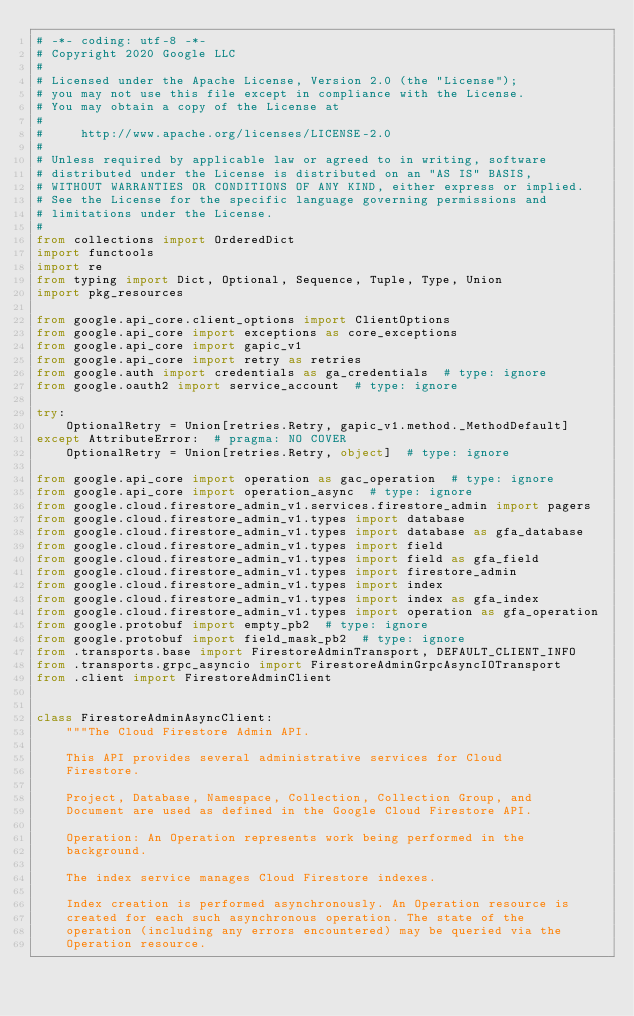<code> <loc_0><loc_0><loc_500><loc_500><_Python_># -*- coding: utf-8 -*-
# Copyright 2020 Google LLC
#
# Licensed under the Apache License, Version 2.0 (the "License");
# you may not use this file except in compliance with the License.
# You may obtain a copy of the License at
#
#     http://www.apache.org/licenses/LICENSE-2.0
#
# Unless required by applicable law or agreed to in writing, software
# distributed under the License is distributed on an "AS IS" BASIS,
# WITHOUT WARRANTIES OR CONDITIONS OF ANY KIND, either express or implied.
# See the License for the specific language governing permissions and
# limitations under the License.
#
from collections import OrderedDict
import functools
import re
from typing import Dict, Optional, Sequence, Tuple, Type, Union
import pkg_resources

from google.api_core.client_options import ClientOptions
from google.api_core import exceptions as core_exceptions
from google.api_core import gapic_v1
from google.api_core import retry as retries
from google.auth import credentials as ga_credentials  # type: ignore
from google.oauth2 import service_account  # type: ignore

try:
    OptionalRetry = Union[retries.Retry, gapic_v1.method._MethodDefault]
except AttributeError:  # pragma: NO COVER
    OptionalRetry = Union[retries.Retry, object]  # type: ignore

from google.api_core import operation as gac_operation  # type: ignore
from google.api_core import operation_async  # type: ignore
from google.cloud.firestore_admin_v1.services.firestore_admin import pagers
from google.cloud.firestore_admin_v1.types import database
from google.cloud.firestore_admin_v1.types import database as gfa_database
from google.cloud.firestore_admin_v1.types import field
from google.cloud.firestore_admin_v1.types import field as gfa_field
from google.cloud.firestore_admin_v1.types import firestore_admin
from google.cloud.firestore_admin_v1.types import index
from google.cloud.firestore_admin_v1.types import index as gfa_index
from google.cloud.firestore_admin_v1.types import operation as gfa_operation
from google.protobuf import empty_pb2  # type: ignore
from google.protobuf import field_mask_pb2  # type: ignore
from .transports.base import FirestoreAdminTransport, DEFAULT_CLIENT_INFO
from .transports.grpc_asyncio import FirestoreAdminGrpcAsyncIOTransport
from .client import FirestoreAdminClient


class FirestoreAdminAsyncClient:
    """The Cloud Firestore Admin API.

    This API provides several administrative services for Cloud
    Firestore.

    Project, Database, Namespace, Collection, Collection Group, and
    Document are used as defined in the Google Cloud Firestore API.

    Operation: An Operation represents work being performed in the
    background.

    The index service manages Cloud Firestore indexes.

    Index creation is performed asynchronously. An Operation resource is
    created for each such asynchronous operation. The state of the
    operation (including any errors encountered) may be queried via the
    Operation resource.
</code> 